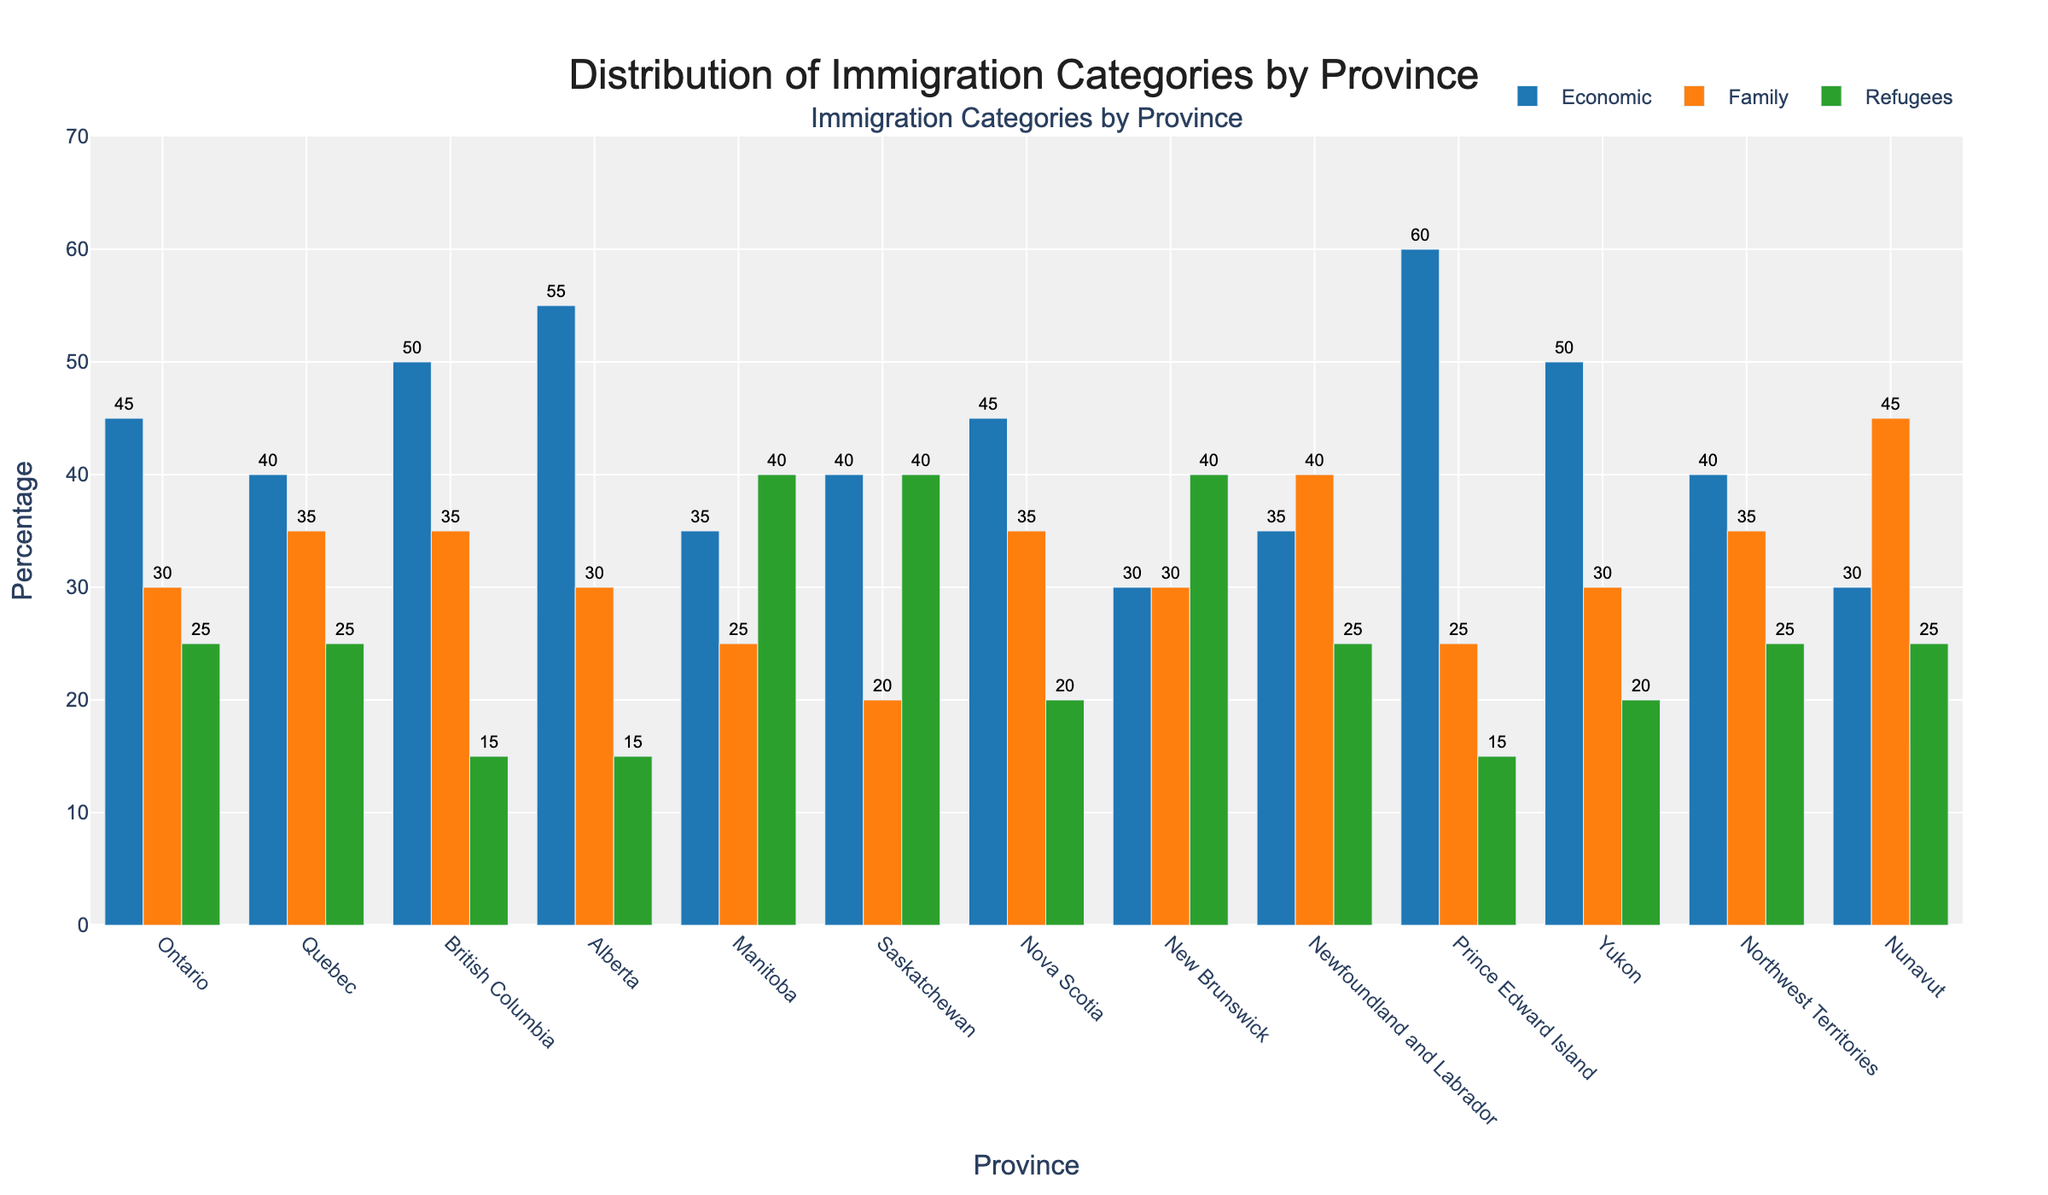Which province has the highest percentage of Economic immigrants? To find the province with the highest percentage of Economic immigrants, look for the tallest bar in the 'Economic' category. Prince Edward Island has the tallest bar in blue, indicating 60%.
Answer: Prince Edward Island Which category has the least percentage of immigrants in Ontario? Compare the heights of the three bars for Ontario. The green bar (Refugees) is the shortest, indicating 25%.
Answer: Refugees What is the total percentage of immigrants in the Family category for Quebec and Alberta combined? Add the values of the Family category for Quebec (35%) and Alberta (30%). 35 + 30 = 65.
Answer: 65% Which province has an equal percentage of Family and Refugee immigrants? Look for provinces where the heights of the orange and green bars are the same. New Brunswick shows this pattern, with both categories at 30%.
Answer: New Brunswick Which province has the highest percentage of Refugees? Identify the tallest green bar, which represents the Refugees category. Both Manitoba and Saskatchewan have the tallest bars for Refugees at 40%.
Answer: Manitoba and Saskatchewan What is the difference in the percentage of Economic immigrants between Alberta and Manitoba? Subtract the percentage of Economic immigrants in Manitoba (35%) from Alberta (55%). 55 - 35 = 20.
Answer: 20% In which province do Family immigrants represent the highest percentage of total immigrants compared to other categories? Look for the province where the orange bar (Family) is the tallest compared to blue and green bars. Newfoundland and Labrador has the highest Family immigrant percentage at 40%.
Answer: Newfoundland and Labrador What is the average percentage of Economic immigrants in Yukon, Northwest Territories, and Nunavut? Calculate the average: (50% for Yukon + 40% for Northwest Territories + 30% for Nunavut) / 3. (50 + 40 + 30) / 3 = 40%.
Answer: 40% Which two provinces have the same percentage of Economic immigrants? Compare the blue bars and find the matching heights. Quebec and Saskatchewan both have 40% Economic immigrants.
Answer: Quebec and Saskatchewan Is the percentage of Family immigrants higher in Nova Scotia or British Columbia? Compare the heights of the orange bars for Nova Scotia and British Columbia. Nova Scotia has 35%, and British Columbia also has 35%, making them equal.
Answer: Equal 